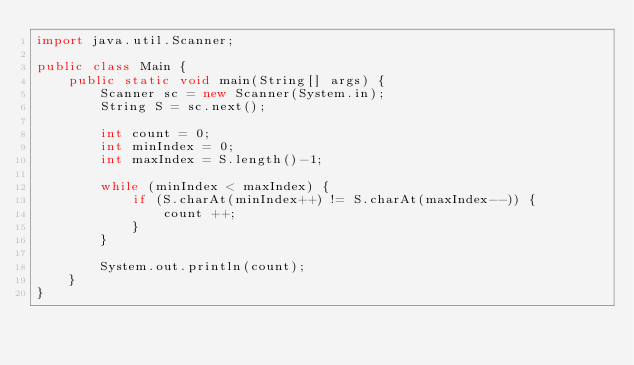Convert code to text. <code><loc_0><loc_0><loc_500><loc_500><_Java_>import java.util.Scanner;

public class Main {
    public static void main(String[] args) {
        Scanner sc = new Scanner(System.in);
        String S = sc.next();
        
        int count = 0;
        int minIndex = 0;
        int maxIndex = S.length()-1;
        
        while (minIndex < maxIndex) {
            if (S.charAt(minIndex++) != S.charAt(maxIndex--)) {
                count ++;
            }
        }
        
        System.out.println(count);
    }
}</code> 